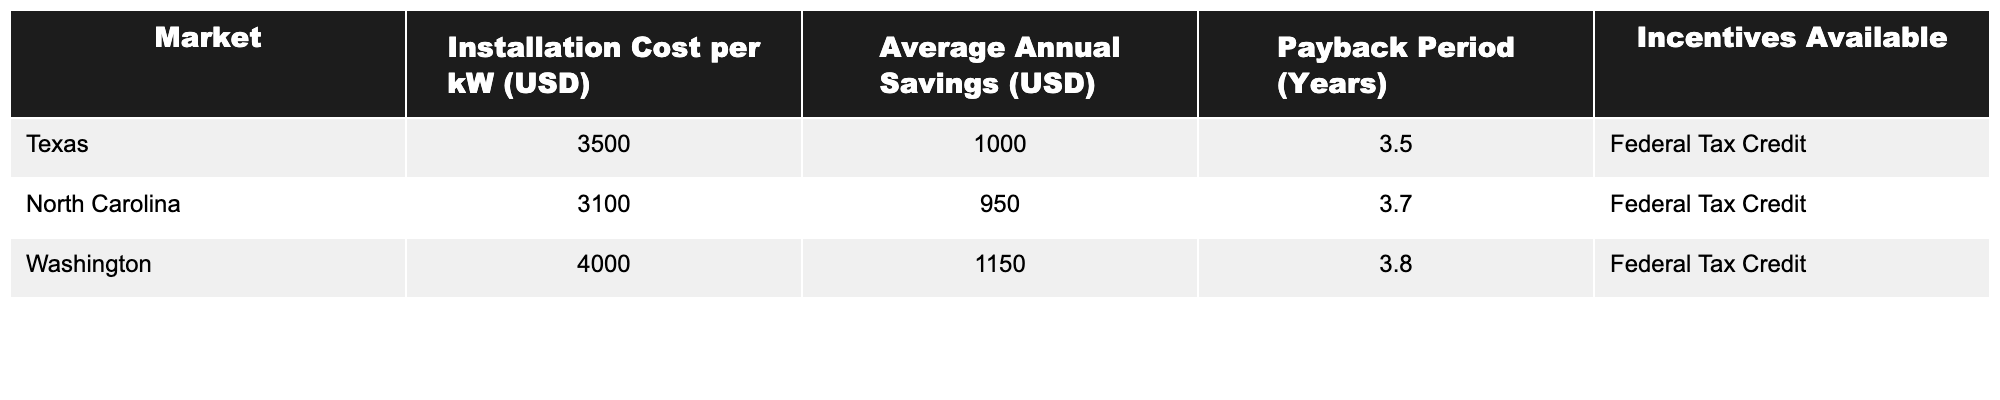What is the installation cost per kW in Texas? The table lists the installation cost per kW in Texas as 3500 USD.
Answer: 3500 USD What is the average annual savings in Washington? According to the table, the average annual savings in Washington is 1150 USD.
Answer: 1150 USD Which state has the lowest installation cost per kW? The table shows that North Carolina has the lowest installation cost per kW at 3100 USD.
Answer: North Carolina What is the payback period for solar energy systems in Texas? The payback period listed for Texas in the table is 3.5 years.
Answer: 3.5 years Are federal tax credits available in all markets listed? Yes, the table indicates that federal tax credits are available for all listed markets.
Answer: Yes What is the difference in average annual savings between Texas and North Carolina? Texas has average annual savings of 1000 USD, while North Carolina has 950 USD. The difference is 1000 - 950 = 50 USD.
Answer: 50 USD Which market has the highest payback period? The table indicates that Washington has the highest payback period at 3.8 years.
Answer: Washington If you sum up the installation costs per kW for Texas and North Carolina, what is the total? Texas has an installation cost of 3500 USD and North Carolina has 3100 USD. Thus, the total is 3500 + 3100 = 6600 USD.
Answer: 6600 USD What are the average annual savings across the three markets? Adding the average annual savings: 1000 (Texas) + 950 (North Carolina) + 1150 (Washington) = 3100 USD; then divide by 3 markets: 3100 / 3 = approximately 1033.33 USD.
Answer: 1033.33 USD Which market offers the highest average annual savings, and by how much compared to the lowest? Washington has the highest average annual savings at 1150 USD, while North Carolina has the lowest at 950 USD. The difference is 1150 - 950 = 200 USD.
Answer: Washington; 200 USD 